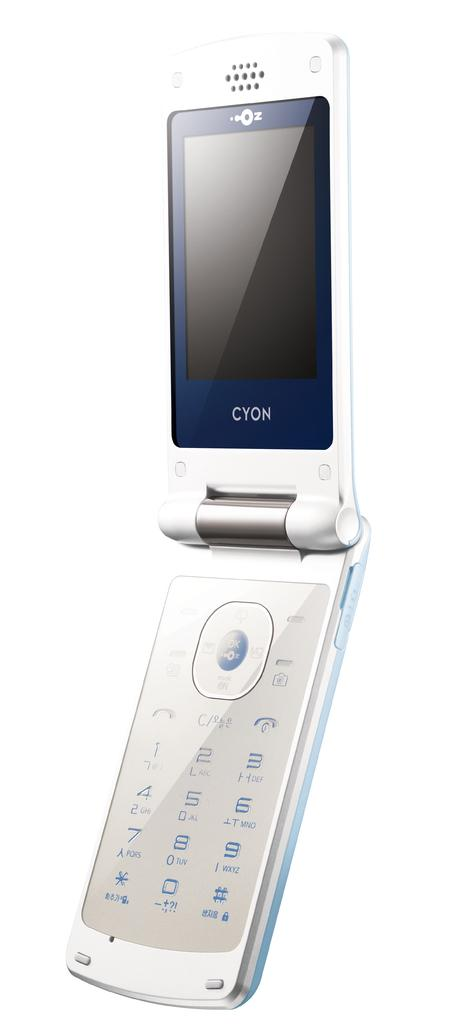<image>
Present a compact description of the photo's key features. A Cyon flip phone is displayed open against a white background. 